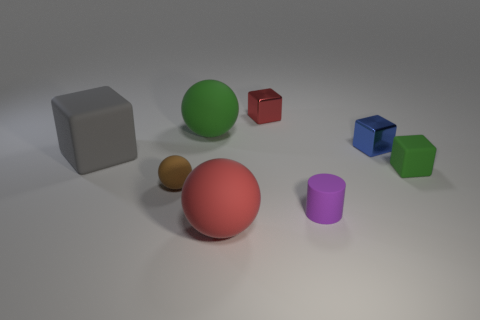The small sphere has what color?
Make the answer very short. Brown. Is the number of gray matte objects in front of the gray rubber thing greater than the number of red rubber balls that are to the right of the red matte sphere?
Ensure brevity in your answer.  No. There is a small blue shiny object; is its shape the same as the big red object in front of the tiny blue shiny cube?
Ensure brevity in your answer.  No. Do the green thing right of the large red object and the ball that is behind the tiny green block have the same size?
Your answer should be compact. No. Is there a metal thing in front of the red object in front of the green matte thing in front of the big gray matte thing?
Your answer should be very brief. No. Is the number of small blocks in front of the tiny green matte thing less than the number of tiny brown objects right of the blue block?
Your answer should be compact. No. There is a blue object that is the same material as the red block; what shape is it?
Ensure brevity in your answer.  Cube. There is a rubber block on the left side of the sphere that is in front of the small thing that is to the left of the large red rubber thing; what is its size?
Provide a succinct answer. Large. Is the number of cyan matte cubes greater than the number of brown rubber spheres?
Offer a terse response. No. Does the big rubber object in front of the tiny brown object have the same color as the small rubber object that is to the left of the red matte object?
Give a very brief answer. No. 